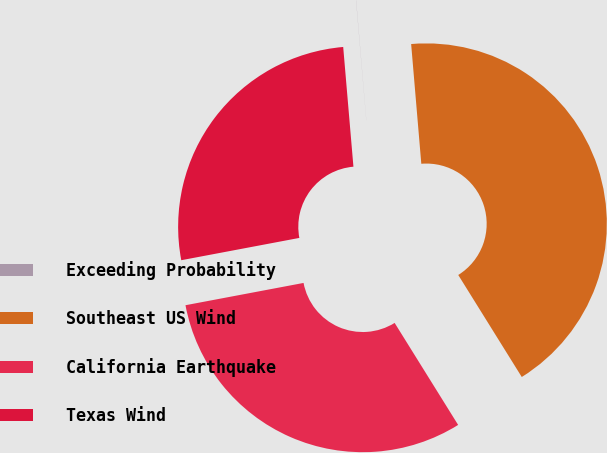Convert chart to OTSL. <chart><loc_0><loc_0><loc_500><loc_500><pie_chart><fcel>Exceeding Probability<fcel>Southeast US Wind<fcel>California Earthquake<fcel>Texas Wind<nl><fcel>0.01%<fcel>42.48%<fcel>30.89%<fcel>26.61%<nl></chart> 